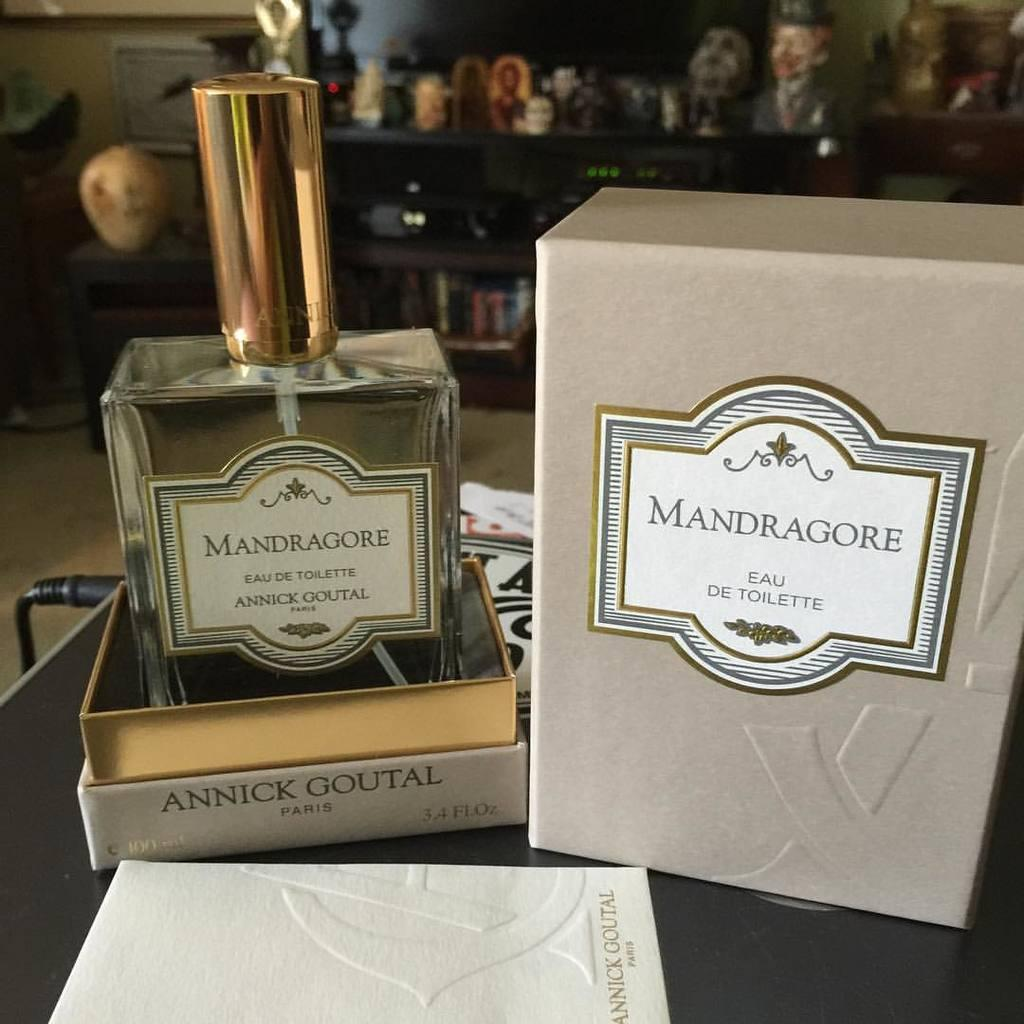<image>
Relay a brief, clear account of the picture shown. A bottle of and box for Mandragore Eau De Toilette. 